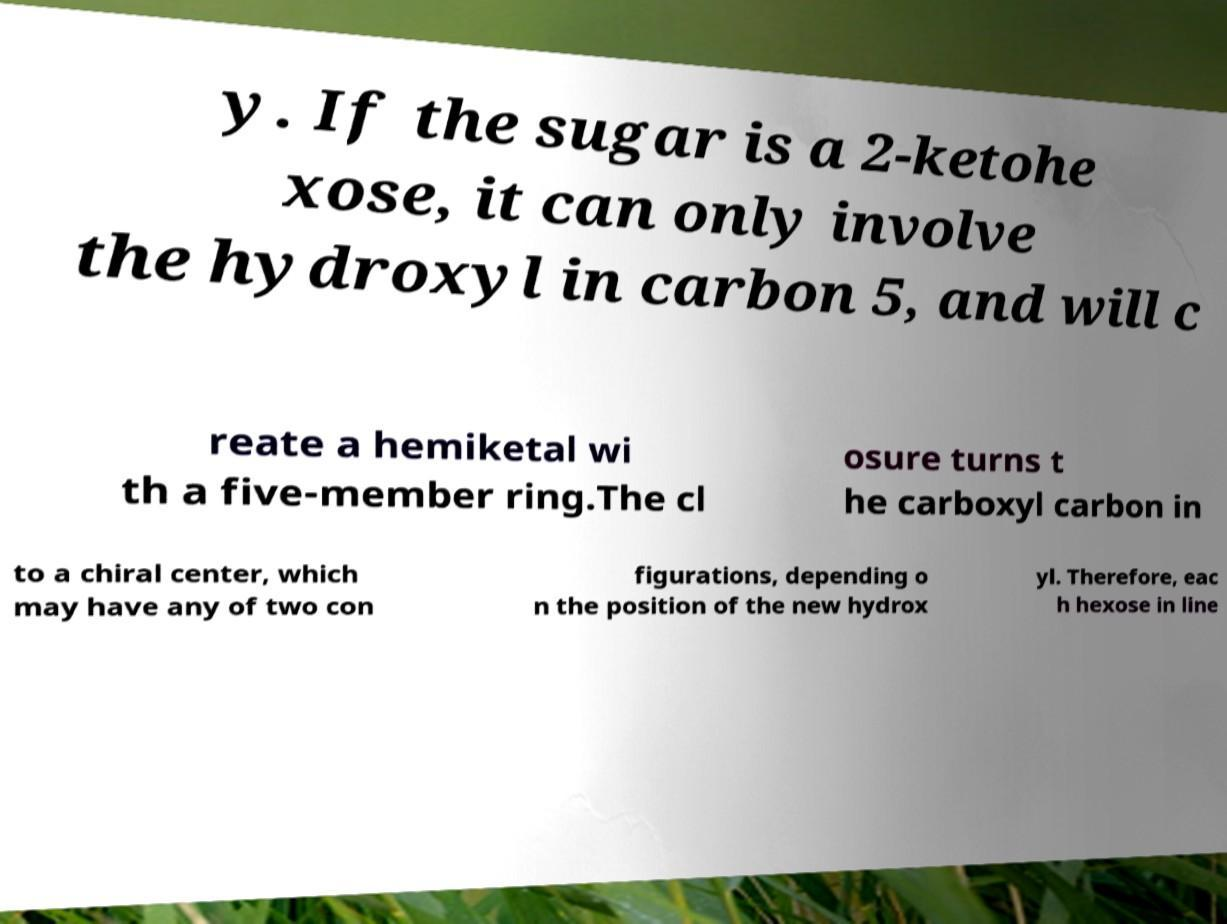I need the written content from this picture converted into text. Can you do that? y. If the sugar is a 2-ketohe xose, it can only involve the hydroxyl in carbon 5, and will c reate a hemiketal wi th a five-member ring.The cl osure turns t he carboxyl carbon in to a chiral center, which may have any of two con figurations, depending o n the position of the new hydrox yl. Therefore, eac h hexose in line 